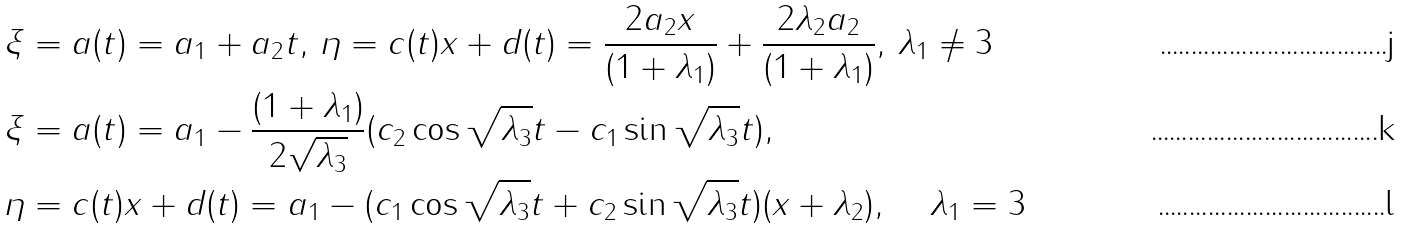Convert formula to latex. <formula><loc_0><loc_0><loc_500><loc_500>& \xi = a ( t ) = a _ { 1 } + a _ { 2 } t , \, \eta = c ( t ) x + d ( t ) = \frac { 2 a _ { 2 } x } { ( 1 + \lambda _ { 1 } ) } + \frac { 2 \lambda _ { 2 } a _ { 2 } } { ( 1 + \lambda _ { 1 } ) } , \, \lambda _ { 1 } \neq 3 \\ & \xi = a ( t ) = a _ { 1 } - \frac { ( 1 + \lambda _ { 1 } ) } { 2 \sqrt { \lambda _ { 3 } } } ( c _ { 2 } \cos \sqrt { \lambda _ { 3 } } t - c _ { 1 } \sin \sqrt { \lambda _ { 3 } } t ) , \\ & \eta = c ( t ) x + d ( t ) = a _ { 1 } - ( c _ { 1 } \cos \sqrt { \lambda _ { 3 } } t + c _ { 2 } \sin \sqrt { \lambda _ { 3 } } t ) ( x + \lambda _ { 2 } ) , \quad \, \lambda _ { 1 } = 3</formula> 